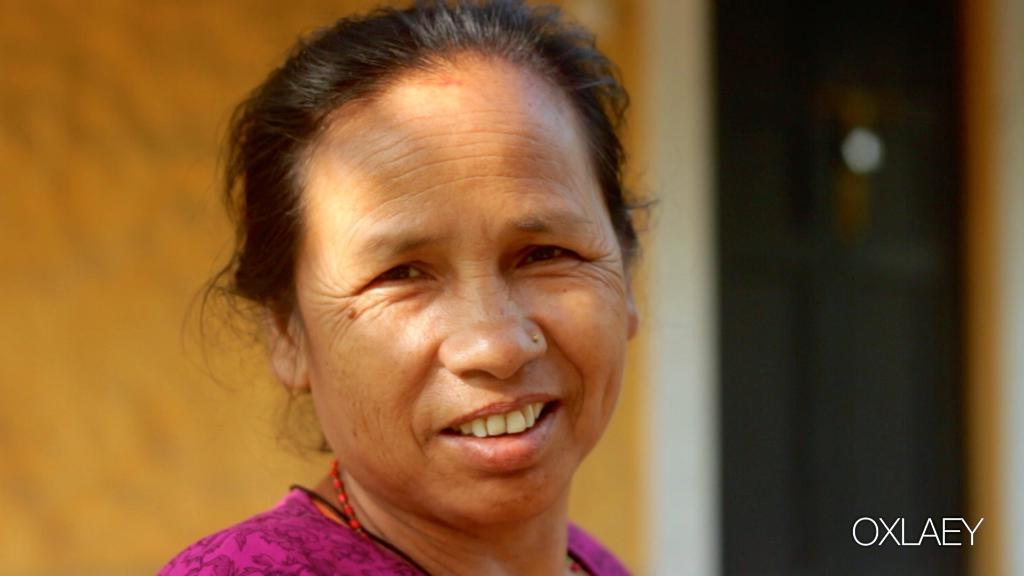Who is the main subject in the image? There is a woman in the middle of the image. What can be seen in the background of the image? There is a wall in the background of the image. What type of jam is the woman spreading on the range in the image? There is no jam or range present in the image; it only features a woman and a wall in the background. 